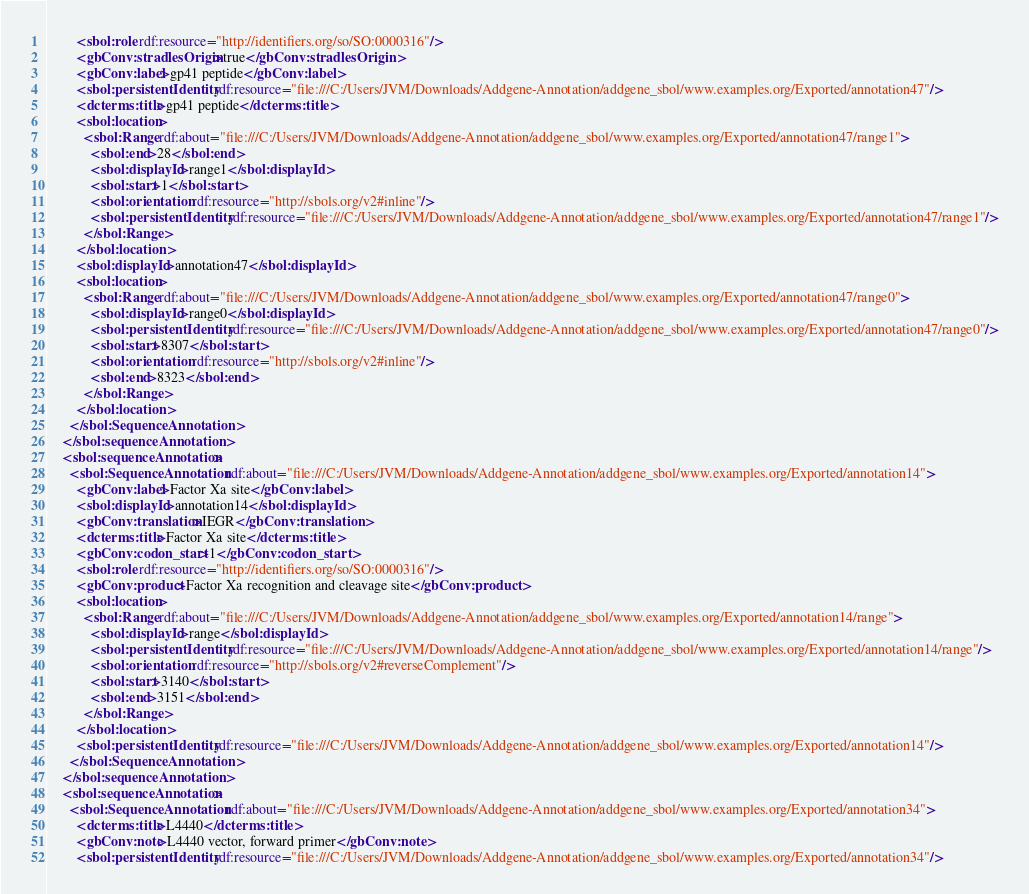<code> <loc_0><loc_0><loc_500><loc_500><_XML_>        <sbol:role rdf:resource="http://identifiers.org/so/SO:0000316"/>
        <gbConv:stradlesOrigin>true</gbConv:stradlesOrigin>
        <gbConv:label>gp41 peptide</gbConv:label>
        <sbol:persistentIdentity rdf:resource="file:///C:/Users/JVM/Downloads/Addgene-Annotation/addgene_sbol/www.examples.org/Exported/annotation47"/>
        <dcterms:title>gp41 peptide</dcterms:title>
        <sbol:location>
          <sbol:Range rdf:about="file:///C:/Users/JVM/Downloads/Addgene-Annotation/addgene_sbol/www.examples.org/Exported/annotation47/range1">
            <sbol:end>28</sbol:end>
            <sbol:displayId>range1</sbol:displayId>
            <sbol:start>1</sbol:start>
            <sbol:orientation rdf:resource="http://sbols.org/v2#inline"/>
            <sbol:persistentIdentity rdf:resource="file:///C:/Users/JVM/Downloads/Addgene-Annotation/addgene_sbol/www.examples.org/Exported/annotation47/range1"/>
          </sbol:Range>
        </sbol:location>
        <sbol:displayId>annotation47</sbol:displayId>
        <sbol:location>
          <sbol:Range rdf:about="file:///C:/Users/JVM/Downloads/Addgene-Annotation/addgene_sbol/www.examples.org/Exported/annotation47/range0">
            <sbol:displayId>range0</sbol:displayId>
            <sbol:persistentIdentity rdf:resource="file:///C:/Users/JVM/Downloads/Addgene-Annotation/addgene_sbol/www.examples.org/Exported/annotation47/range0"/>
            <sbol:start>8307</sbol:start>
            <sbol:orientation rdf:resource="http://sbols.org/v2#inline"/>
            <sbol:end>8323</sbol:end>
          </sbol:Range>
        </sbol:location>
      </sbol:SequenceAnnotation>
    </sbol:sequenceAnnotation>
    <sbol:sequenceAnnotation>
      <sbol:SequenceAnnotation rdf:about="file:///C:/Users/JVM/Downloads/Addgene-Annotation/addgene_sbol/www.examples.org/Exported/annotation14">
        <gbConv:label>Factor Xa site</gbConv:label>
        <sbol:displayId>annotation14</sbol:displayId>
        <gbConv:translation>IEGR</gbConv:translation>
        <dcterms:title>Factor Xa site</dcterms:title>
        <gbConv:codon_start>1</gbConv:codon_start>
        <sbol:role rdf:resource="http://identifiers.org/so/SO:0000316"/>
        <gbConv:product>Factor Xa recognition and cleavage site</gbConv:product>
        <sbol:location>
          <sbol:Range rdf:about="file:///C:/Users/JVM/Downloads/Addgene-Annotation/addgene_sbol/www.examples.org/Exported/annotation14/range">
            <sbol:displayId>range</sbol:displayId>
            <sbol:persistentIdentity rdf:resource="file:///C:/Users/JVM/Downloads/Addgene-Annotation/addgene_sbol/www.examples.org/Exported/annotation14/range"/>
            <sbol:orientation rdf:resource="http://sbols.org/v2#reverseComplement"/>
            <sbol:start>3140</sbol:start>
            <sbol:end>3151</sbol:end>
          </sbol:Range>
        </sbol:location>
        <sbol:persistentIdentity rdf:resource="file:///C:/Users/JVM/Downloads/Addgene-Annotation/addgene_sbol/www.examples.org/Exported/annotation14"/>
      </sbol:SequenceAnnotation>
    </sbol:sequenceAnnotation>
    <sbol:sequenceAnnotation>
      <sbol:SequenceAnnotation rdf:about="file:///C:/Users/JVM/Downloads/Addgene-Annotation/addgene_sbol/www.examples.org/Exported/annotation34">
        <dcterms:title>L4440</dcterms:title>
        <gbConv:note>L4440 vector, forward primer</gbConv:note>
        <sbol:persistentIdentity rdf:resource="file:///C:/Users/JVM/Downloads/Addgene-Annotation/addgene_sbol/www.examples.org/Exported/annotation34"/></code> 